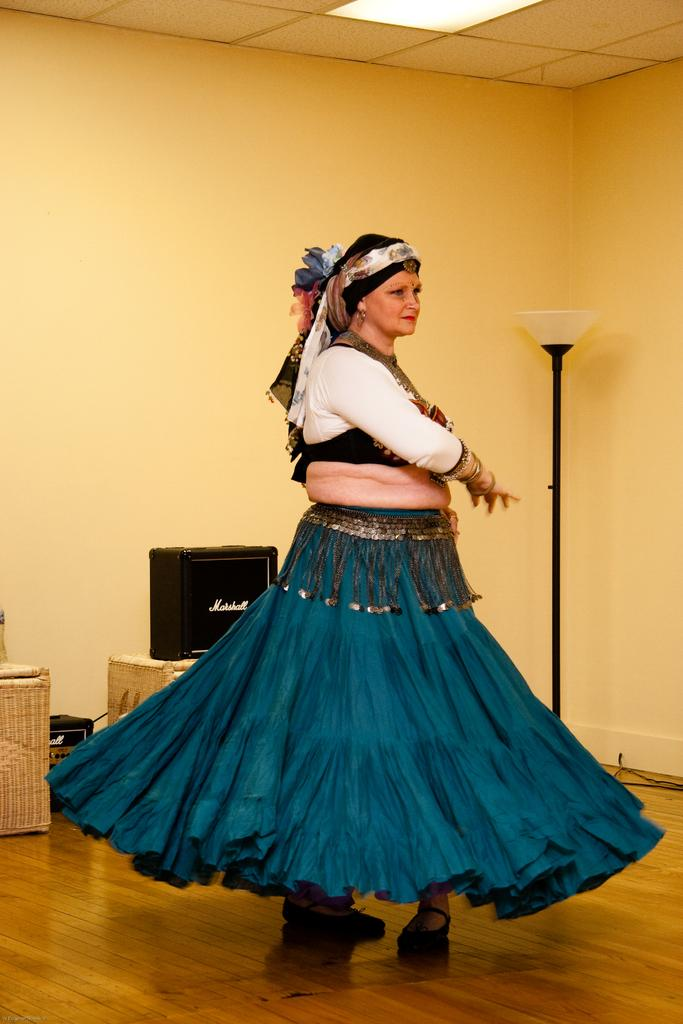Who is the main subject in the image? There is a woman in the image. What is the woman wearing? The woman is wearing a sea green frock and a white top. What is the woman doing in the image? The woman is doing belly dance. Where is the dance taking place? The dance is taking place on a wooden floor. What can be seen in the image that might be related to the music? There are speakers visible in the image. What type of lighting is present in the image? There is a light over the ceiling. How many women are there in the image, and what is their limit for dancing? There is only one woman in the image, and there is no mention of any limit for dancing. Is there a train visible in the image? No, there is no train present in the image. 